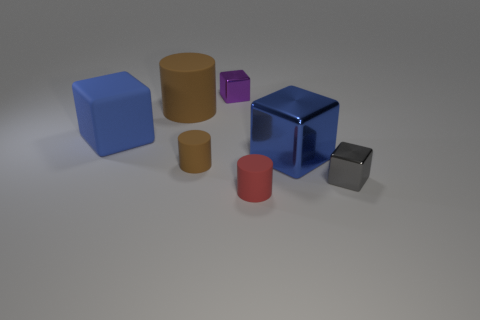Subtract all small gray metallic cubes. How many cubes are left? 3 Subtract all gray blocks. How many blocks are left? 3 Subtract all blocks. How many objects are left? 3 Subtract 1 cylinders. How many cylinders are left? 2 Add 3 big yellow metal cubes. How many objects exist? 10 Subtract all purple cubes. Subtract all purple cylinders. How many cubes are left? 3 Subtract all blue spheres. How many gray cubes are left? 1 Subtract all large blue things. Subtract all small cyan matte cylinders. How many objects are left? 5 Add 2 gray things. How many gray things are left? 3 Add 7 rubber cubes. How many rubber cubes exist? 8 